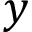Convert formula to latex. <formula><loc_0><loc_0><loc_500><loc_500>y</formula> 